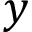Convert formula to latex. <formula><loc_0><loc_0><loc_500><loc_500>y</formula> 